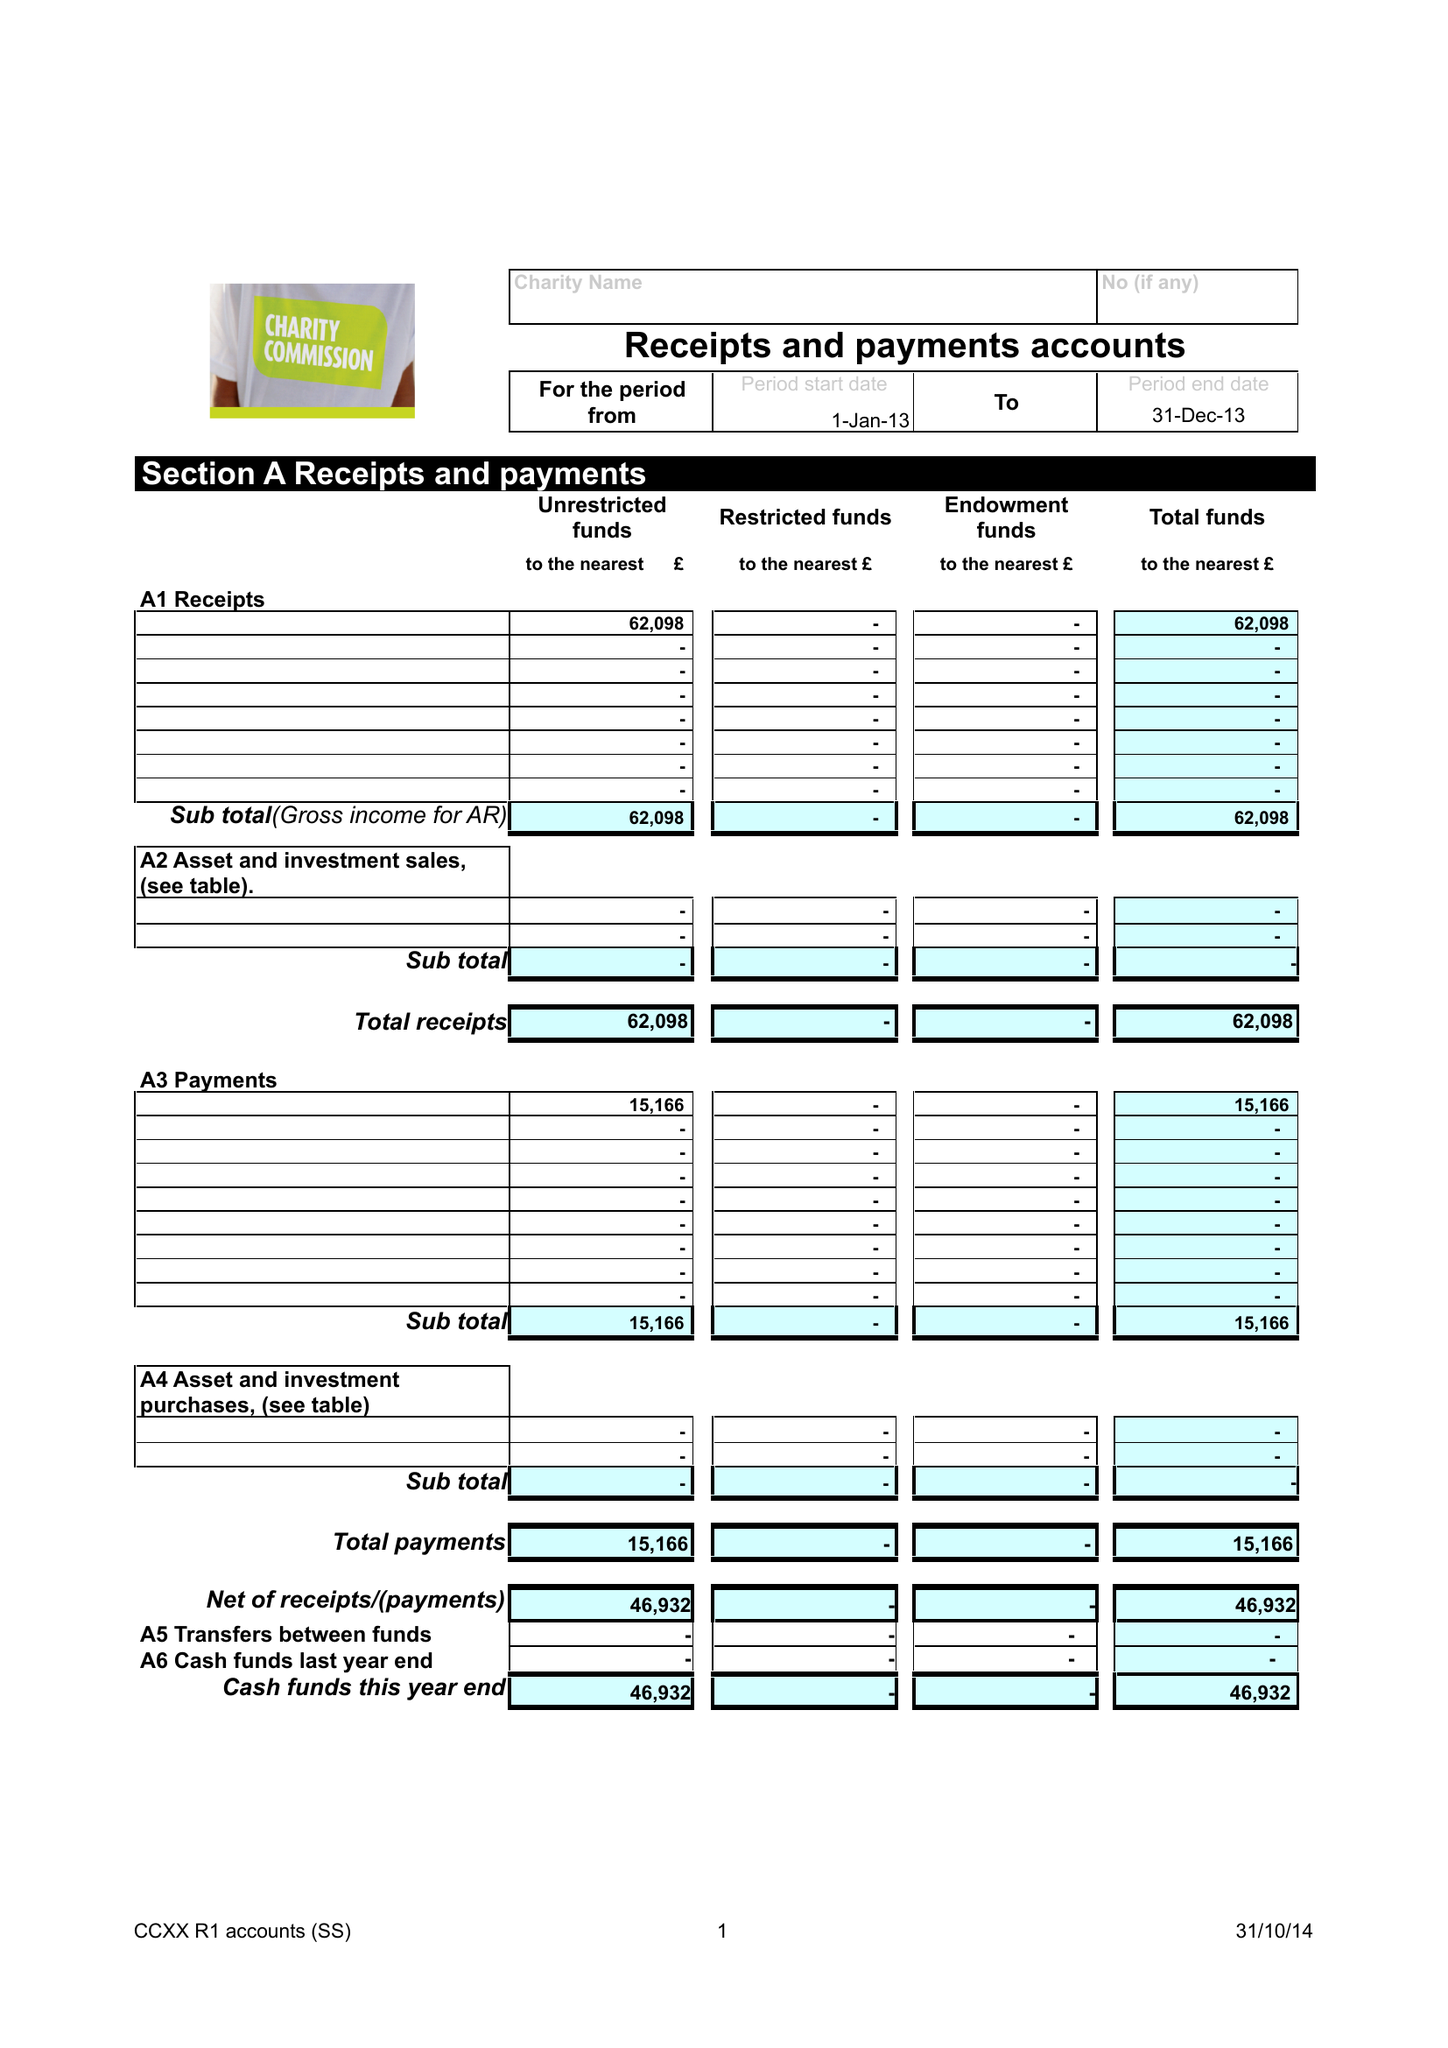What is the value for the address__post_town?
Answer the question using a single word or phrase. CARMARTHEN 